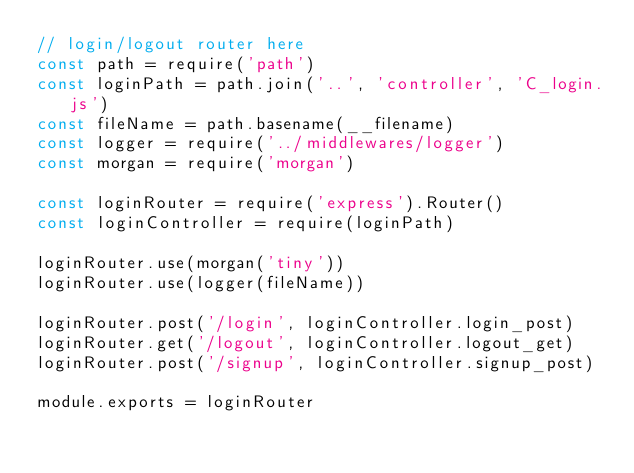Convert code to text. <code><loc_0><loc_0><loc_500><loc_500><_JavaScript_>// login/logout router here
const path = require('path')
const loginPath = path.join('..', 'controller', 'C_login.js')
const fileName = path.basename(__filename)
const logger = require('../middlewares/logger')
const morgan = require('morgan')

const loginRouter = require('express').Router()
const loginController = require(loginPath)

loginRouter.use(morgan('tiny'))
loginRouter.use(logger(fileName))

loginRouter.post('/login', loginController.login_post)
loginRouter.get('/logout', loginController.logout_get)
loginRouter.post('/signup', loginController.signup_post)

module.exports = loginRouter</code> 